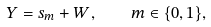Convert formula to latex. <formula><loc_0><loc_0><loc_500><loc_500>Y = s _ { m } + W , \quad m \in \{ 0 , 1 \} ,</formula> 